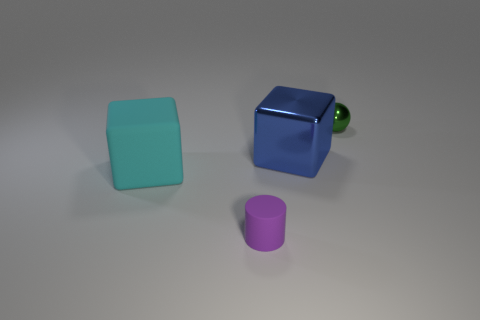Add 1 gray cylinders. How many objects exist? 5 Subtract all spheres. How many objects are left? 3 Subtract all blue cylinders. Subtract all yellow blocks. How many cylinders are left? 1 Subtract all red spheres. How many blue blocks are left? 1 Subtract all green metal cubes. Subtract all big blue shiny things. How many objects are left? 3 Add 3 small spheres. How many small spheres are left? 4 Add 2 big purple rubber blocks. How many big purple rubber blocks exist? 2 Subtract 1 purple cylinders. How many objects are left? 3 